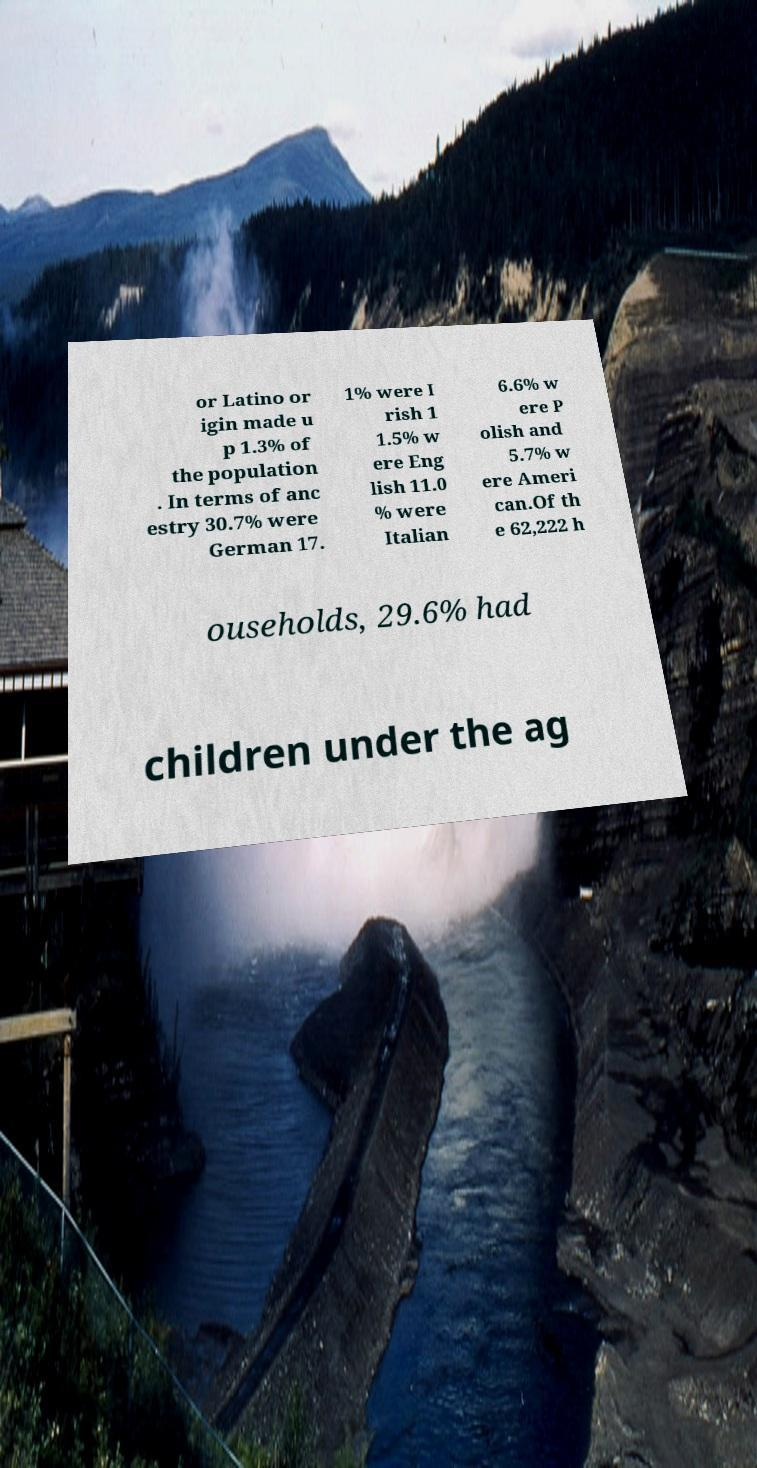Can you accurately transcribe the text from the provided image for me? or Latino or igin made u p 1.3% of the population . In terms of anc estry 30.7% were German 17. 1% were I rish 1 1.5% w ere Eng lish 11.0 % were Italian 6.6% w ere P olish and 5.7% w ere Ameri can.Of th e 62,222 h ouseholds, 29.6% had children under the ag 